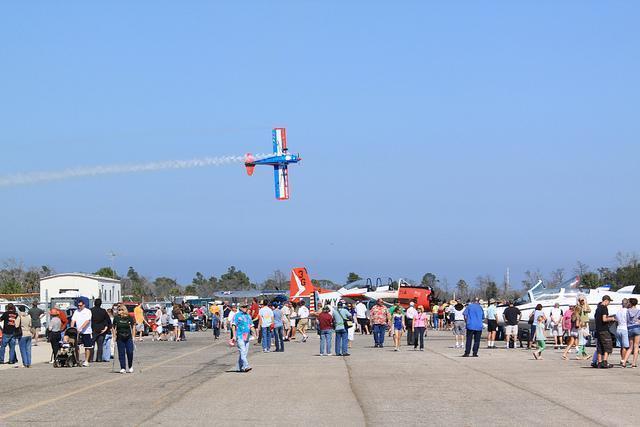Who will be riding those planes?
Make your selection and explain in format: 'Answer: answer
Rationale: rationale.'
Options: Airforce, animals, passengers, stunt pilots. Answer: stunt pilots.
Rationale: The planes are doing tricks in the air and only have enough space one or two people. 